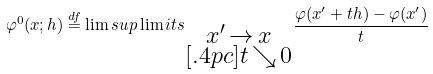<formula> <loc_0><loc_0><loc_500><loc_500>\varphi ^ { 0 } ( x ; h ) \stackrel { d f } { = } \lim s u p \lim i t s _ { \substack { x ^ { \prime } \, \rightarrow \, x \\ [ . 4 p c ] t \, \searrow \, 0 } } \frac { \varphi ( x ^ { \prime } + t h ) - \varphi ( x ^ { \prime } ) } { t }</formula> 